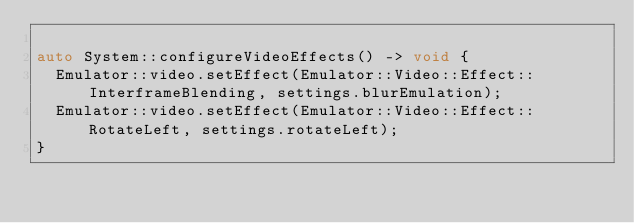Convert code to text. <code><loc_0><loc_0><loc_500><loc_500><_C++_>
auto System::configureVideoEffects() -> void {
  Emulator::video.setEffect(Emulator::Video::Effect::InterframeBlending, settings.blurEmulation);
  Emulator::video.setEffect(Emulator::Video::Effect::RotateLeft, settings.rotateLeft);
}
</code> 